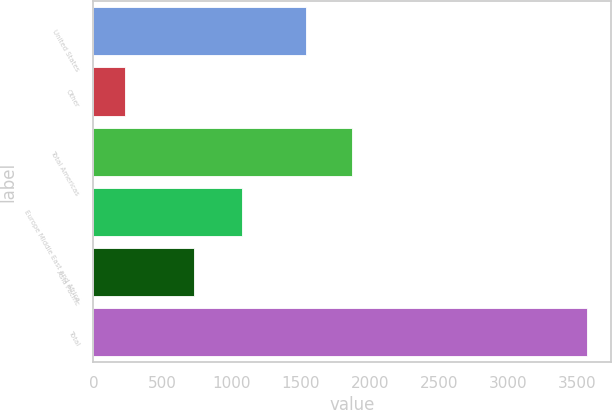Convert chart to OTSL. <chart><loc_0><loc_0><loc_500><loc_500><bar_chart><fcel>United States<fcel>Other<fcel>Total Americas<fcel>Europe Middle East and Africa<fcel>Asia Pacific<fcel>Total<nl><fcel>1537.5<fcel>228.7<fcel>1871.87<fcel>1077.7<fcel>728.5<fcel>3572.4<nl></chart> 